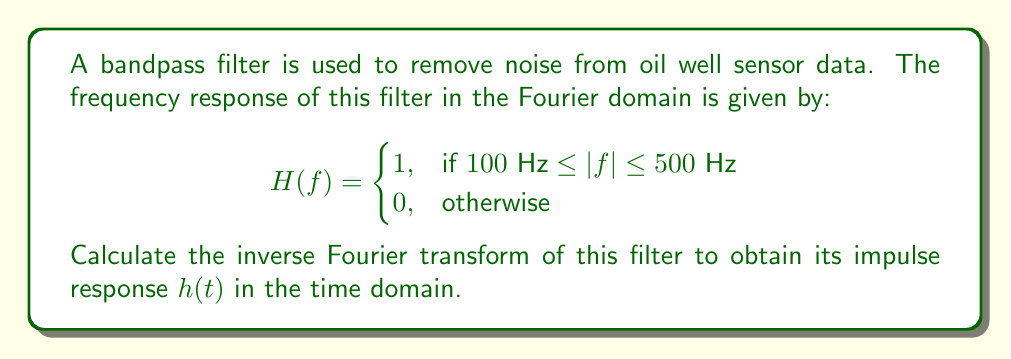Show me your answer to this math problem. To find the inverse Fourier transform of the given frequency response, we need to use the inverse Fourier transform formula:

$$h(t) = \int_{-\infty}^{\infty} H(f) e^{j2\pi ft} df$$

Given the bandpass nature of $H(f)$, we can split the integral into two parts:

$$h(t) = \int_{-500}^{-100} e^{j2\pi ft} df + \int_{100}^{500} e^{j2\pi ft} df$$

Let's solve each integral separately:

1) For the negative frequency band:
   $$\int_{-500}^{-100} e^{j2\pi ft} df = \frac{1}{j2\pi t}[e^{j2\pi ft}]_{-500}^{-100} = \frac{1}{j2\pi t}(e^{-j200\pi t} - e^{-j1000\pi t})$$

2) For the positive frequency band:
   $$\int_{100}^{500} e^{j2\pi ft} df = \frac{1}{j2\pi t}[e^{j2\pi ft}]_{100}^{500} = \frac{1}{j2\pi t}(e^{j1000\pi t} - e^{j200\pi t})$$

Combining these results:

$$h(t) = \frac{1}{j2\pi t}(e^{-j200\pi t} - e^{-j1000\pi t} + e^{j1000\pi t} - e^{j200\pi t})$$

Using Euler's formula ($e^{jx} = \cos(x) + j\sin(x)$), we can simplify this to:

$$h(t) = \frac{1}{\pi t}(\sin(1000\pi t) - \sin(200\pi t))$$

This is the impulse response of the bandpass filter in the time domain.
Answer: $$h(t) = \frac{1}{\pi t}(\sin(1000\pi t) - \sin(200\pi t))$$ 